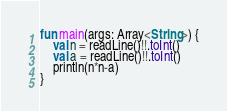<code> <loc_0><loc_0><loc_500><loc_500><_Kotlin_>fun main(args: Array<String>) {
	val n = readLine()!!.toInt()
	val a = readLine()!!.toInt()
	println(n*n-a)
}

</code> 